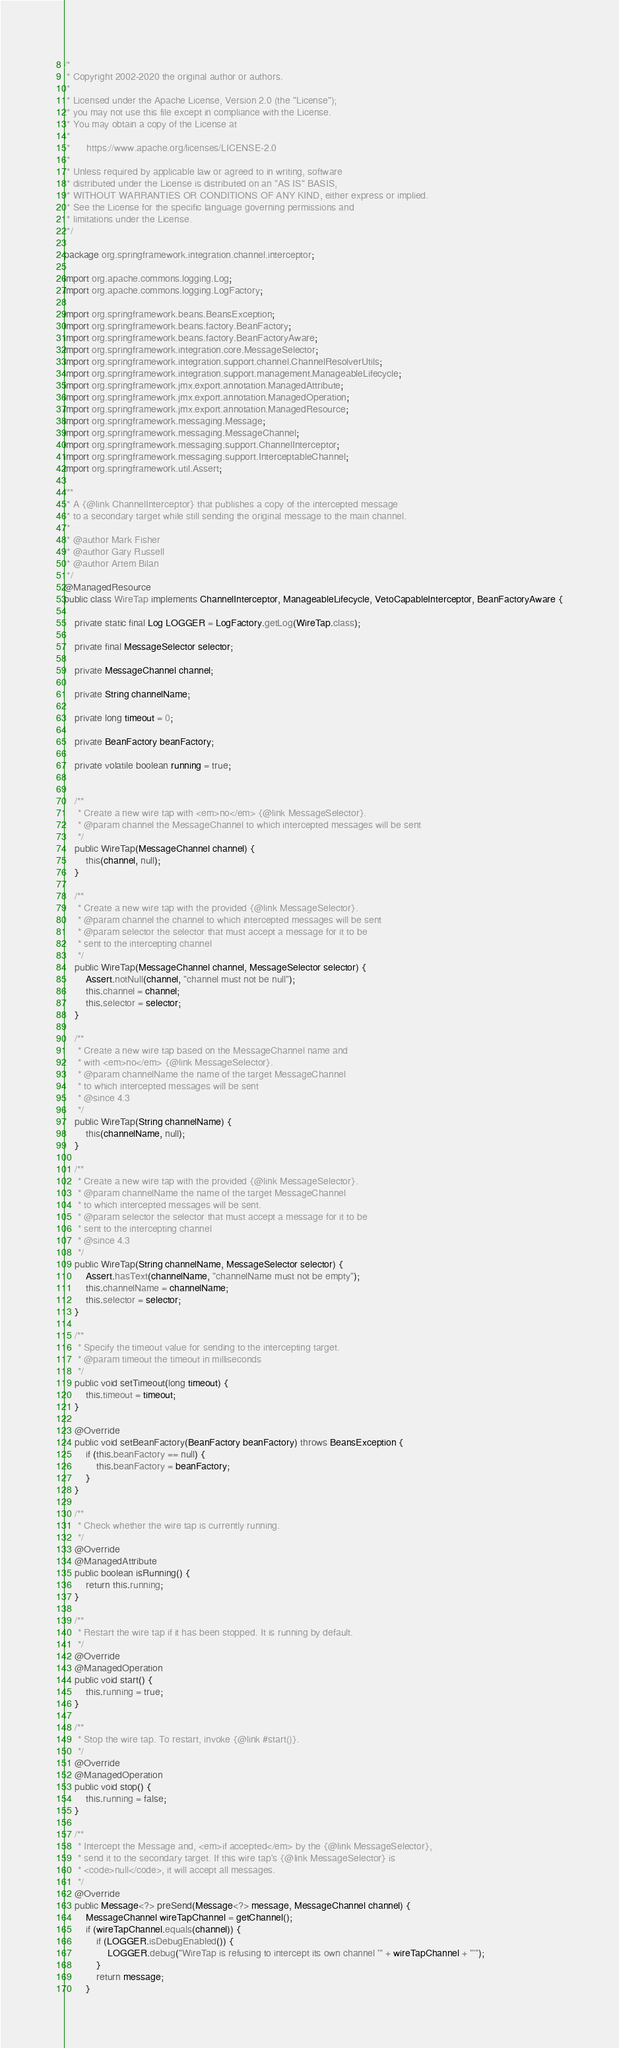<code> <loc_0><loc_0><loc_500><loc_500><_Java_>/*
 * Copyright 2002-2020 the original author or authors.
 *
 * Licensed under the Apache License, Version 2.0 (the "License");
 * you may not use this file except in compliance with the License.
 * You may obtain a copy of the License at
 *
 *      https://www.apache.org/licenses/LICENSE-2.0
 *
 * Unless required by applicable law or agreed to in writing, software
 * distributed under the License is distributed on an "AS IS" BASIS,
 * WITHOUT WARRANTIES OR CONDITIONS OF ANY KIND, either express or implied.
 * See the License for the specific language governing permissions and
 * limitations under the License.
 */

package org.springframework.integration.channel.interceptor;

import org.apache.commons.logging.Log;
import org.apache.commons.logging.LogFactory;

import org.springframework.beans.BeansException;
import org.springframework.beans.factory.BeanFactory;
import org.springframework.beans.factory.BeanFactoryAware;
import org.springframework.integration.core.MessageSelector;
import org.springframework.integration.support.channel.ChannelResolverUtils;
import org.springframework.integration.support.management.ManageableLifecycle;
import org.springframework.jmx.export.annotation.ManagedAttribute;
import org.springframework.jmx.export.annotation.ManagedOperation;
import org.springframework.jmx.export.annotation.ManagedResource;
import org.springframework.messaging.Message;
import org.springframework.messaging.MessageChannel;
import org.springframework.messaging.support.ChannelInterceptor;
import org.springframework.messaging.support.InterceptableChannel;
import org.springframework.util.Assert;

/**
 * A {@link ChannelInterceptor} that publishes a copy of the intercepted message
 * to a secondary target while still sending the original message to the main channel.
 *
 * @author Mark Fisher
 * @author Gary Russell
 * @author Artem Bilan
 */
@ManagedResource
public class WireTap implements ChannelInterceptor, ManageableLifecycle, VetoCapableInterceptor, BeanFactoryAware {

	private static final Log LOGGER = LogFactory.getLog(WireTap.class);

	private final MessageSelector selector;

	private MessageChannel channel;

	private String channelName;

	private long timeout = 0;

	private BeanFactory beanFactory;

	private volatile boolean running = true;


	/**
	 * Create a new wire tap with <em>no</em> {@link MessageSelector}.
	 * @param channel the MessageChannel to which intercepted messages will be sent
	 */
	public WireTap(MessageChannel channel) {
		this(channel, null);
	}

	/**
	 * Create a new wire tap with the provided {@link MessageSelector}.
	 * @param channel the channel to which intercepted messages will be sent
	 * @param selector the selector that must accept a message for it to be
	 * sent to the intercepting channel
	 */
	public WireTap(MessageChannel channel, MessageSelector selector) {
		Assert.notNull(channel, "channel must not be null");
		this.channel = channel;
		this.selector = selector;
	}

	/**
	 * Create a new wire tap based on the MessageChannel name and
	 * with <em>no</em> {@link MessageSelector}.
	 * @param channelName the name of the target MessageChannel
	 * to which intercepted messages will be sent
	 * @since 4.3
	 */
	public WireTap(String channelName) {
		this(channelName, null);
	}

	/**
	 * Create a new wire tap with the provided {@link MessageSelector}.
	 * @param channelName the name of the target MessageChannel
	 * to which intercepted messages will be sent.
	 * @param selector the selector that must accept a message for it to be
	 * sent to the intercepting channel
	 * @since 4.3
	 */
	public WireTap(String channelName, MessageSelector selector) {
		Assert.hasText(channelName, "channelName must not be empty");
		this.channelName = channelName;
		this.selector = selector;
	}

	/**
	 * Specify the timeout value for sending to the intercepting target.
	 * @param timeout the timeout in milliseconds
	 */
	public void setTimeout(long timeout) {
		this.timeout = timeout;
	}

	@Override
	public void setBeanFactory(BeanFactory beanFactory) throws BeansException {
		if (this.beanFactory == null) {
			this.beanFactory = beanFactory;
		}
	}

	/**
	 * Check whether the wire tap is currently running.
	 */
	@Override
	@ManagedAttribute
	public boolean isRunning() {
		return this.running;
	}

	/**
	 * Restart the wire tap if it has been stopped. It is running by default.
	 */
	@Override
	@ManagedOperation
	public void start() {
		this.running = true;
	}

	/**
	 * Stop the wire tap. To restart, invoke {@link #start()}.
	 */
	@Override
	@ManagedOperation
	public void stop() {
		this.running = false;
	}

	/**
	 * Intercept the Message and, <em>if accepted</em> by the {@link MessageSelector},
	 * send it to the secondary target. If this wire tap's {@link MessageSelector} is
	 * <code>null</code>, it will accept all messages.
	 */
	@Override
	public Message<?> preSend(Message<?> message, MessageChannel channel) {
		MessageChannel wireTapChannel = getChannel();
		if (wireTapChannel.equals(channel)) {
			if (LOGGER.isDebugEnabled()) {
				LOGGER.debug("WireTap is refusing to intercept its own channel '" + wireTapChannel + "'");
			}
			return message;
		}</code> 